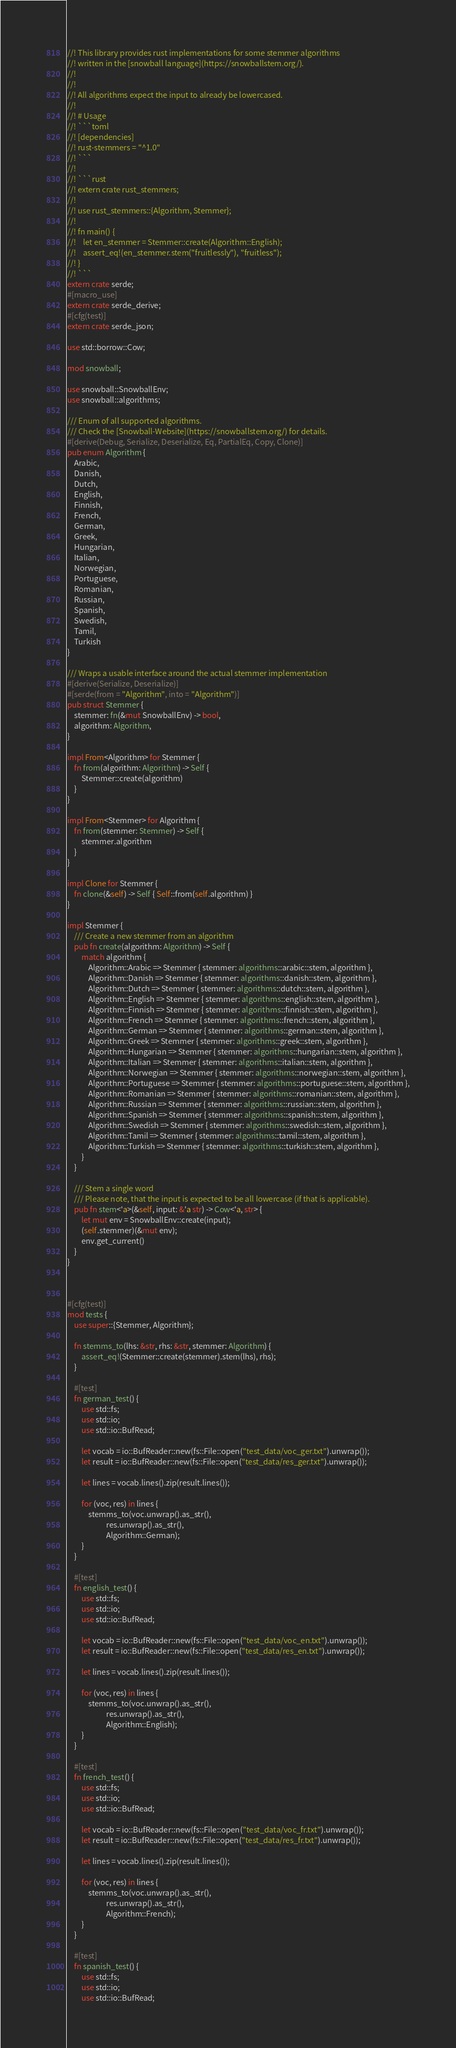Convert code to text. <code><loc_0><loc_0><loc_500><loc_500><_Rust_>//! This library provides rust implementations for some stemmer algorithms
//! written in the [snowball language](https://snowballstem.org/).
//!
//!
//! All algorithms expect the input to already be lowercased.
//!
//! # Usage
//! ```toml
//! [dependencies]
//! rust-stemmers = "^1.0"
//! ```
//!
//! ```rust
//! extern crate rust_stemmers;
//!
//! use rust_stemmers::{Algorithm, Stemmer};
//!
//! fn main() {
//!    let en_stemmer = Stemmer::create(Algorithm::English);
//!    assert_eq!(en_stemmer.stem("fruitlessly"), "fruitless");
//! }
//! ```
extern crate serde;
#[macro_use]
extern crate serde_derive;
#[cfg(test)]
extern crate serde_json;

use std::borrow::Cow;

mod snowball;

use snowball::SnowballEnv;
use snowball::algorithms;

/// Enum of all supported algorithms.
/// Check the [Snowball-Website](https://snowballstem.org/) for details.
#[derive(Debug, Serialize, Deserialize, Eq, PartialEq, Copy, Clone)]
pub enum Algorithm {
    Arabic,
    Danish,
    Dutch,
    English,
    Finnish,
    French,
    German,
    Greek,
    Hungarian,
    Italian,
    Norwegian,
    Portuguese,
    Romanian,
    Russian,
    Spanish,
    Swedish,
    Tamil,
    Turkish
}

/// Wraps a usable interface around the actual stemmer implementation
#[derive(Serialize, Deserialize)]
#[serde(from = "Algorithm", into = "Algorithm")]
pub struct Stemmer {
    stemmer: fn(&mut SnowballEnv) -> bool,
    algorithm: Algorithm,
}

impl From<Algorithm> for Stemmer {
    fn from(algorithm: Algorithm) -> Self {
        Stemmer::create(algorithm)
    }
}

impl From<Stemmer> for Algorithm {
    fn from(stemmer: Stemmer) -> Self {
        stemmer.algorithm
    }
}

impl Clone for Stemmer {
    fn clone(&self) -> Self { Self::from(self.algorithm) }
}

impl Stemmer {
    /// Create a new stemmer from an algorithm
    pub fn create(algorithm: Algorithm) -> Self {
        match algorithm {
            Algorithm::Arabic => Stemmer { stemmer: algorithms::arabic::stem, algorithm },
            Algorithm::Danish => Stemmer { stemmer: algorithms::danish::stem, algorithm },
            Algorithm::Dutch => Stemmer { stemmer: algorithms::dutch::stem, algorithm },
            Algorithm::English => Stemmer { stemmer: algorithms::english::stem, algorithm },
            Algorithm::Finnish => Stemmer { stemmer: algorithms::finnish::stem, algorithm },
            Algorithm::French => Stemmer { stemmer: algorithms::french::stem, algorithm },
            Algorithm::German => Stemmer { stemmer: algorithms::german::stem, algorithm },
            Algorithm::Greek => Stemmer { stemmer: algorithms::greek::stem, algorithm },
            Algorithm::Hungarian => Stemmer { stemmer: algorithms::hungarian::stem, algorithm },
            Algorithm::Italian => Stemmer { stemmer: algorithms::italian::stem, algorithm },
            Algorithm::Norwegian => Stemmer { stemmer: algorithms::norwegian::stem, algorithm },
            Algorithm::Portuguese => Stemmer { stemmer: algorithms::portuguese::stem, algorithm },
            Algorithm::Romanian => Stemmer { stemmer: algorithms::romanian::stem, algorithm },
            Algorithm::Russian => Stemmer { stemmer: algorithms::russian::stem, algorithm },
            Algorithm::Spanish => Stemmer { stemmer: algorithms::spanish::stem, algorithm },
            Algorithm::Swedish => Stemmer { stemmer: algorithms::swedish::stem, algorithm },
            Algorithm::Tamil => Stemmer { stemmer: algorithms::tamil::stem, algorithm },
            Algorithm::Turkish => Stemmer { stemmer: algorithms::turkish::stem, algorithm },
        }
    }

    /// Stem a single word
    /// Please note, that the input is expected to be all lowercase (if that is applicable).
    pub fn stem<'a>(&self, input: &'a str) -> Cow<'a, str> {
        let mut env = SnowballEnv::create(input);
        (self.stemmer)(&mut env);
        env.get_current()
    }
}



#[cfg(test)]
mod tests {
    use super::{Stemmer, Algorithm};

    fn stemms_to(lhs: &str, rhs: &str, stemmer: Algorithm) {
        assert_eq!(Stemmer::create(stemmer).stem(lhs), rhs);
    }

    #[test]
    fn german_test() {
        use std::fs;
        use std::io;
        use std::io::BufRead;

        let vocab = io::BufReader::new(fs::File::open("test_data/voc_ger.txt").unwrap());
        let result = io::BufReader::new(fs::File::open("test_data/res_ger.txt").unwrap());

        let lines = vocab.lines().zip(result.lines());

        for (voc, res) in lines {
            stemms_to(voc.unwrap().as_str(),
                      res.unwrap().as_str(),
                      Algorithm::German);
        }
    }

    #[test]
    fn english_test() {
        use std::fs;
        use std::io;
        use std::io::BufRead;

        let vocab = io::BufReader::new(fs::File::open("test_data/voc_en.txt").unwrap());
        let result = io::BufReader::new(fs::File::open("test_data/res_en.txt").unwrap());

        let lines = vocab.lines().zip(result.lines());

        for (voc, res) in lines {
            stemms_to(voc.unwrap().as_str(),
                      res.unwrap().as_str(),
                      Algorithm::English);
        }
    }

    #[test]
    fn french_test() {
        use std::fs;
        use std::io;
        use std::io::BufRead;

        let vocab = io::BufReader::new(fs::File::open("test_data/voc_fr.txt").unwrap());
        let result = io::BufReader::new(fs::File::open("test_data/res_fr.txt").unwrap());

        let lines = vocab.lines().zip(result.lines());

        for (voc, res) in lines {
            stemms_to(voc.unwrap().as_str(),
                      res.unwrap().as_str(),
                      Algorithm::French);
        }
    }

    #[test]
    fn spanish_test() {
        use std::fs;
        use std::io;
        use std::io::BufRead;
</code> 